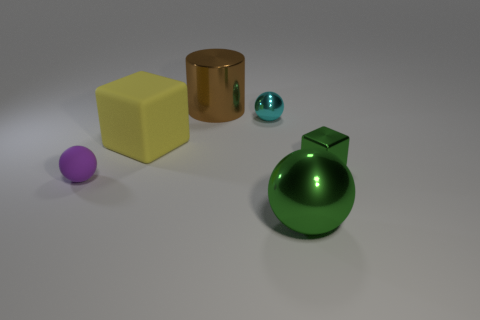How might the sizes of these objects affect their use in a real-world setting? In a real-world setting, the various sizes of these objects suggest different uses. The smaller spheres could serve as decorative elements or bearings in machinery, while the larger cylinder could be a container or a structural component. The cube might be used as a child's toy block or a calibration object for 3D modeling. 